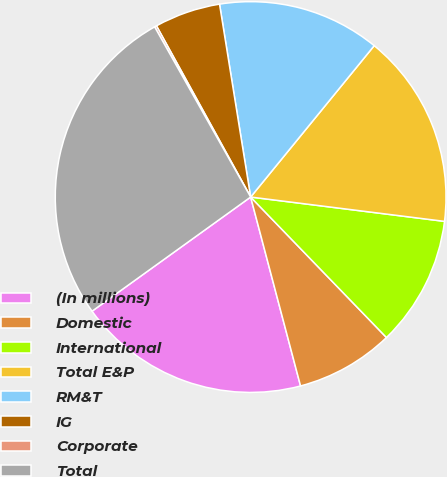<chart> <loc_0><loc_0><loc_500><loc_500><pie_chart><fcel>(In millions)<fcel>Domestic<fcel>International<fcel>Total E&P<fcel>RM&T<fcel>IG<fcel>Corporate<fcel>Total<nl><fcel>19.18%<fcel>8.12%<fcel>10.78%<fcel>16.09%<fcel>13.44%<fcel>5.46%<fcel>0.17%<fcel>26.75%<nl></chart> 